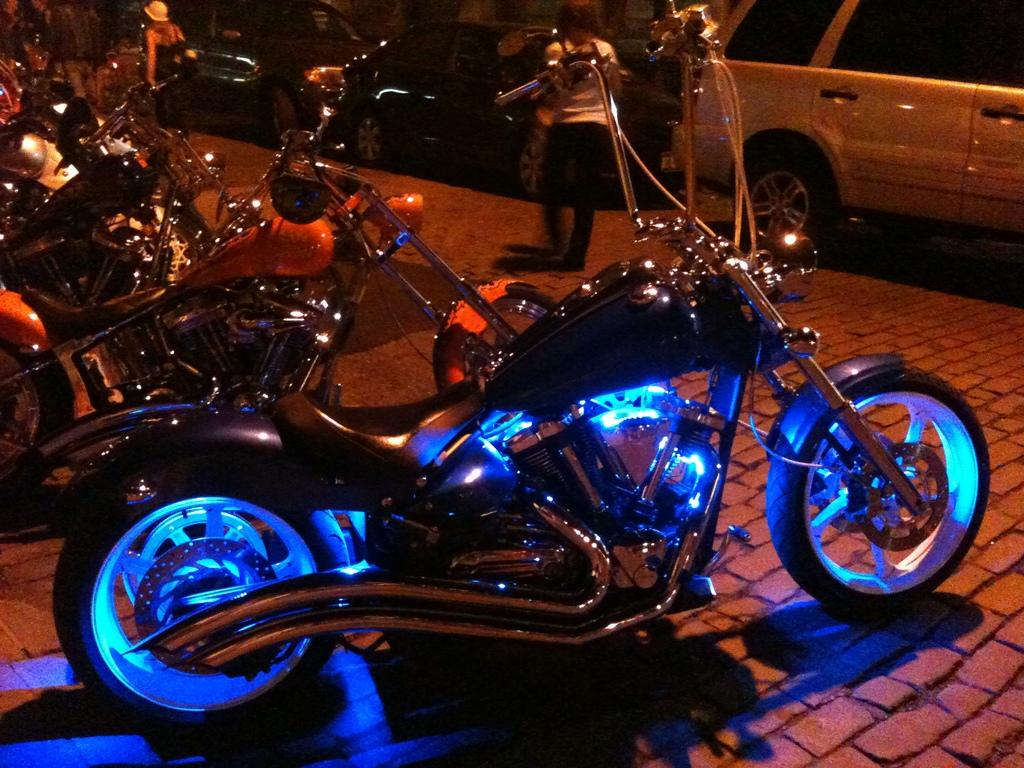What is the main subject in the center of the image? There are bikes in the center of the image. What can be seen in the background of the image? There are people and cars in the background of the image. What type of quince is being used to drain the bikes in the image? There is no quince or draining activity present in the image; it features bikes in the center and people and cars in the background. 